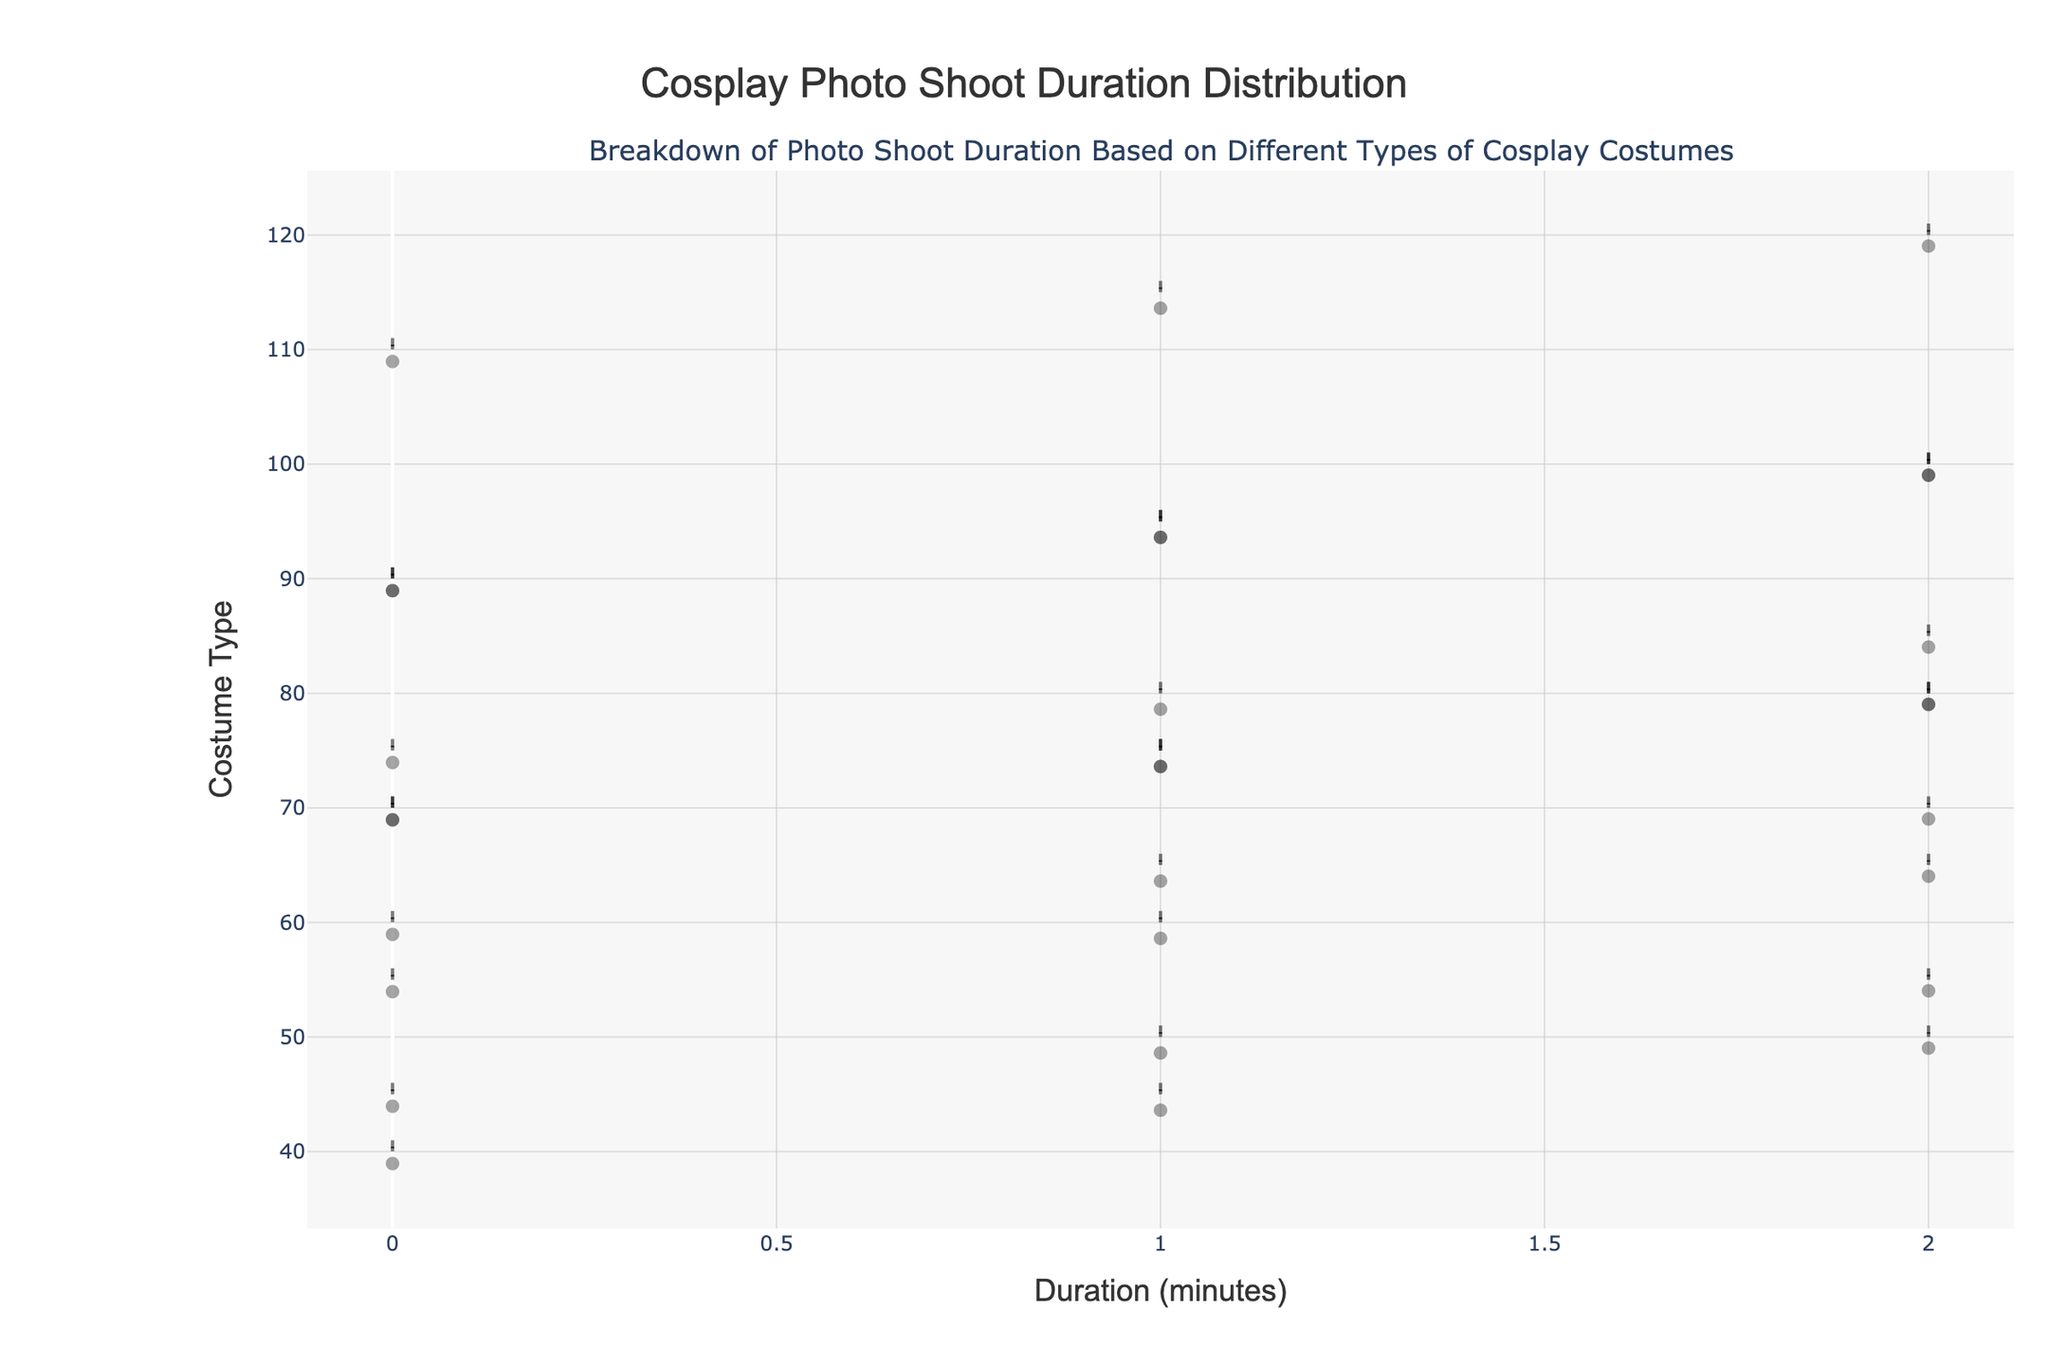What's the title of the chart? The title of the chart is usually located at the top of the figure, it helps in understanding what the chart is about. Here, the title is "Cosplay Photo Shoot Duration Distribution."
Answer: Cosplay Photo Shoot Duration Distribution What is the x-axis label? The x-axis label is provided to indicate what the horizontal axis represents. In this figure, it is indicated as "Duration (minutes)."
Answer: Duration (minutes) How many costume types are illustrated in the chart? To find this, count the unique costume types present in the figure. This comes from the different names on the y-axis.
Answer: 10 Which costume type has the longest average photo shoot duration? The meanline in a violin plot helps us determine the average duration. By examining the means of each costume type, "Fantasy - Witch" shows the longest average duration.
Answer: Fantasy - Witch Which costume type has the most varied photo shoot durations? To determine the variance, look for the widest spread within the violin plots. The costume with the widest distribution is "Fantasy - Witch."
Answer: Fantasy - Witch What is the range of photo shoot durations for Anime - Naruto? The range can be calculated by finding the minimum and maximum values in the plot. For "Anime - Naruto," the minimum is 60, and maximum is 70, making the range 70 - 60 = 10 minutes.
Answer: 10 minutes Which costume types have overlapping ranges of photo shoot durations? By examining the violin plots, you can see which costume types have durations that overlap. "Anime - Sailor Moon" (45-55) and "Superhero - Spider-Man" (40-50) are examples.
Answer: Anime - Sailor Moon and Superhero - Spider-Man Which costume type has the shortest minimum photo shoot duration? The minimum duration is the point closest to the origin on the horizontal axis. "Superhero - Spider-Man" has the shortest minimum duration of 40 minutes.
Answer: Superhero - Spider-Man What is the median photo shoot duration for Steampunk - Engineer? The median is represented by the line inside the box in the violin plot. For "Steampunk - Engineer," the median is at 60 minutes.
Answer: 60 minutes Are any photo shoot durations for Gaming - Lara Croft above 80 minutes? Observing the plot, notice if there are any points beyond 80 minutes within "Gaming - Lara Croft." There are no points beyond this mark.
Answer: No Which costume type has the broadest interquartile range? The interquartile range (IQR) is the box length in a box plot within the violin plot. The broadest IQR appears in "Fantasy - Witch," spanning from 110 to 120.
Answer: Fantasy - Witch 